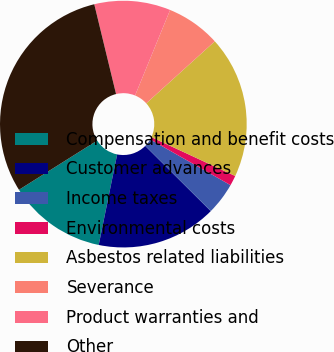Convert chart to OTSL. <chart><loc_0><loc_0><loc_500><loc_500><pie_chart><fcel>Compensation and benefit costs<fcel>Customer advances<fcel>Income taxes<fcel>Environmental costs<fcel>Asbestos related liabilities<fcel>Severance<fcel>Product warranties and<fcel>Other<nl><fcel>12.86%<fcel>15.74%<fcel>4.22%<fcel>1.33%<fcel>18.62%<fcel>7.1%<fcel>9.98%<fcel>30.15%<nl></chart> 